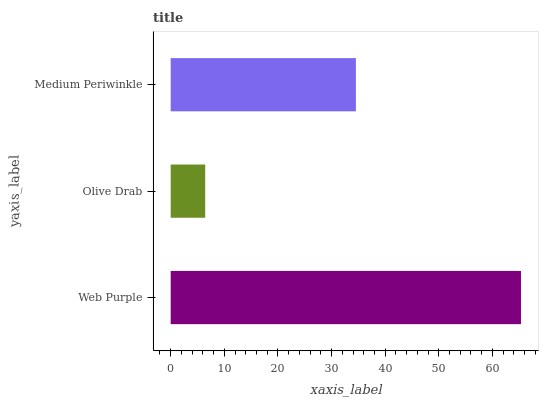Is Olive Drab the minimum?
Answer yes or no. Yes. Is Web Purple the maximum?
Answer yes or no. Yes. Is Medium Periwinkle the minimum?
Answer yes or no. No. Is Medium Periwinkle the maximum?
Answer yes or no. No. Is Medium Periwinkle greater than Olive Drab?
Answer yes or no. Yes. Is Olive Drab less than Medium Periwinkle?
Answer yes or no. Yes. Is Olive Drab greater than Medium Periwinkle?
Answer yes or no. No. Is Medium Periwinkle less than Olive Drab?
Answer yes or no. No. Is Medium Periwinkle the high median?
Answer yes or no. Yes. Is Medium Periwinkle the low median?
Answer yes or no. Yes. Is Olive Drab the high median?
Answer yes or no. No. Is Olive Drab the low median?
Answer yes or no. No. 